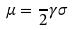Convert formula to latex. <formula><loc_0><loc_0><loc_500><loc_500>\mu = \frac { } { 2 } \gamma \sigma</formula> 